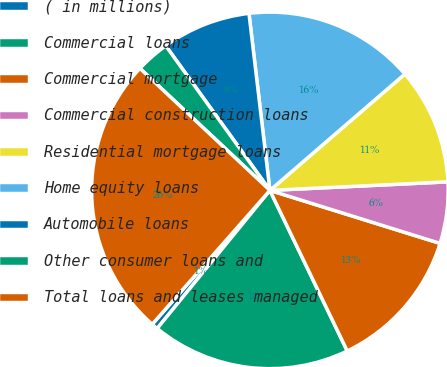Convert chart to OTSL. <chart><loc_0><loc_0><loc_500><loc_500><pie_chart><fcel>( in millions)<fcel>Commercial loans<fcel>Commercial mortgage<fcel>Commercial construction loans<fcel>Residential mortgage loans<fcel>Home equity loans<fcel>Automobile loans<fcel>Other consumer loans and<fcel>Total loans and leases managed<nl><fcel>0.58%<fcel>18.04%<fcel>13.05%<fcel>5.57%<fcel>10.56%<fcel>15.55%<fcel>8.06%<fcel>3.07%<fcel>25.52%<nl></chart> 